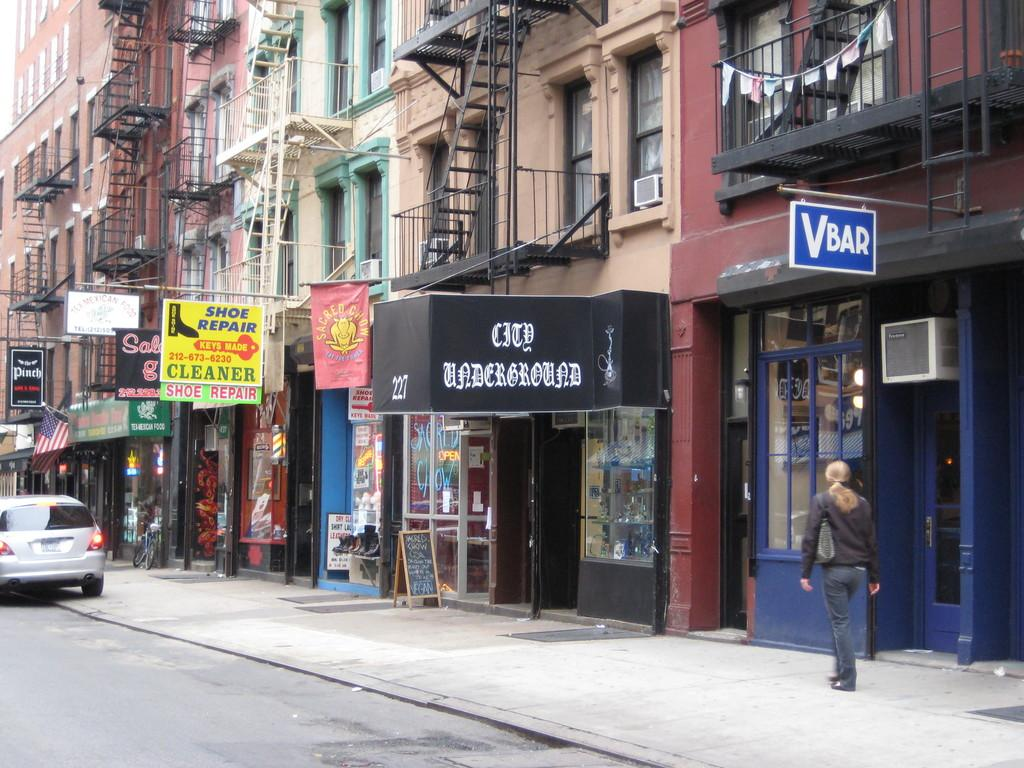What type of structures can be seen in the image? There are buildings in the image. What else is present on the buildings or nearby? There are boards with text in the image. Can you describe any activity happening in the image? There is a person walking in the image. What mode of transportation can be seen in the image? There is a car on the road in the image. What type of apparatus is being used by the robin in the image? There is no robin present in the image, and therefore no apparatus can be associated with it. 